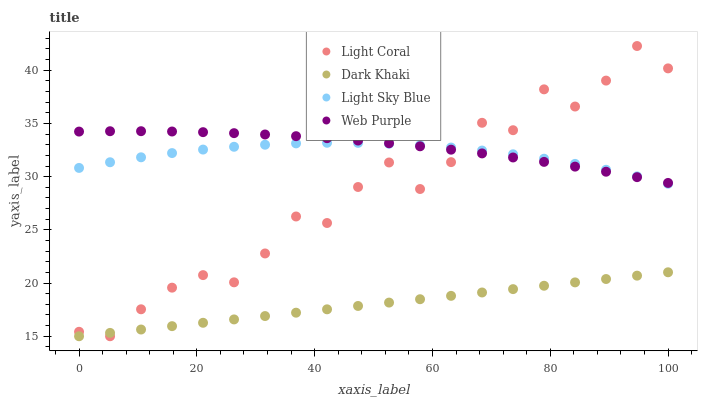Does Dark Khaki have the minimum area under the curve?
Answer yes or no. Yes. Does Web Purple have the maximum area under the curve?
Answer yes or no. Yes. Does Web Purple have the minimum area under the curve?
Answer yes or no. No. Does Dark Khaki have the maximum area under the curve?
Answer yes or no. No. Is Dark Khaki the smoothest?
Answer yes or no. Yes. Is Light Coral the roughest?
Answer yes or no. Yes. Is Web Purple the smoothest?
Answer yes or no. No. Is Web Purple the roughest?
Answer yes or no. No. Does Light Coral have the lowest value?
Answer yes or no. Yes. Does Web Purple have the lowest value?
Answer yes or no. No. Does Light Coral have the highest value?
Answer yes or no. Yes. Does Web Purple have the highest value?
Answer yes or no. No. Is Dark Khaki less than Web Purple?
Answer yes or no. Yes. Is Web Purple greater than Dark Khaki?
Answer yes or no. Yes. Does Light Sky Blue intersect Light Coral?
Answer yes or no. Yes. Is Light Sky Blue less than Light Coral?
Answer yes or no. No. Is Light Sky Blue greater than Light Coral?
Answer yes or no. No. Does Dark Khaki intersect Web Purple?
Answer yes or no. No. 